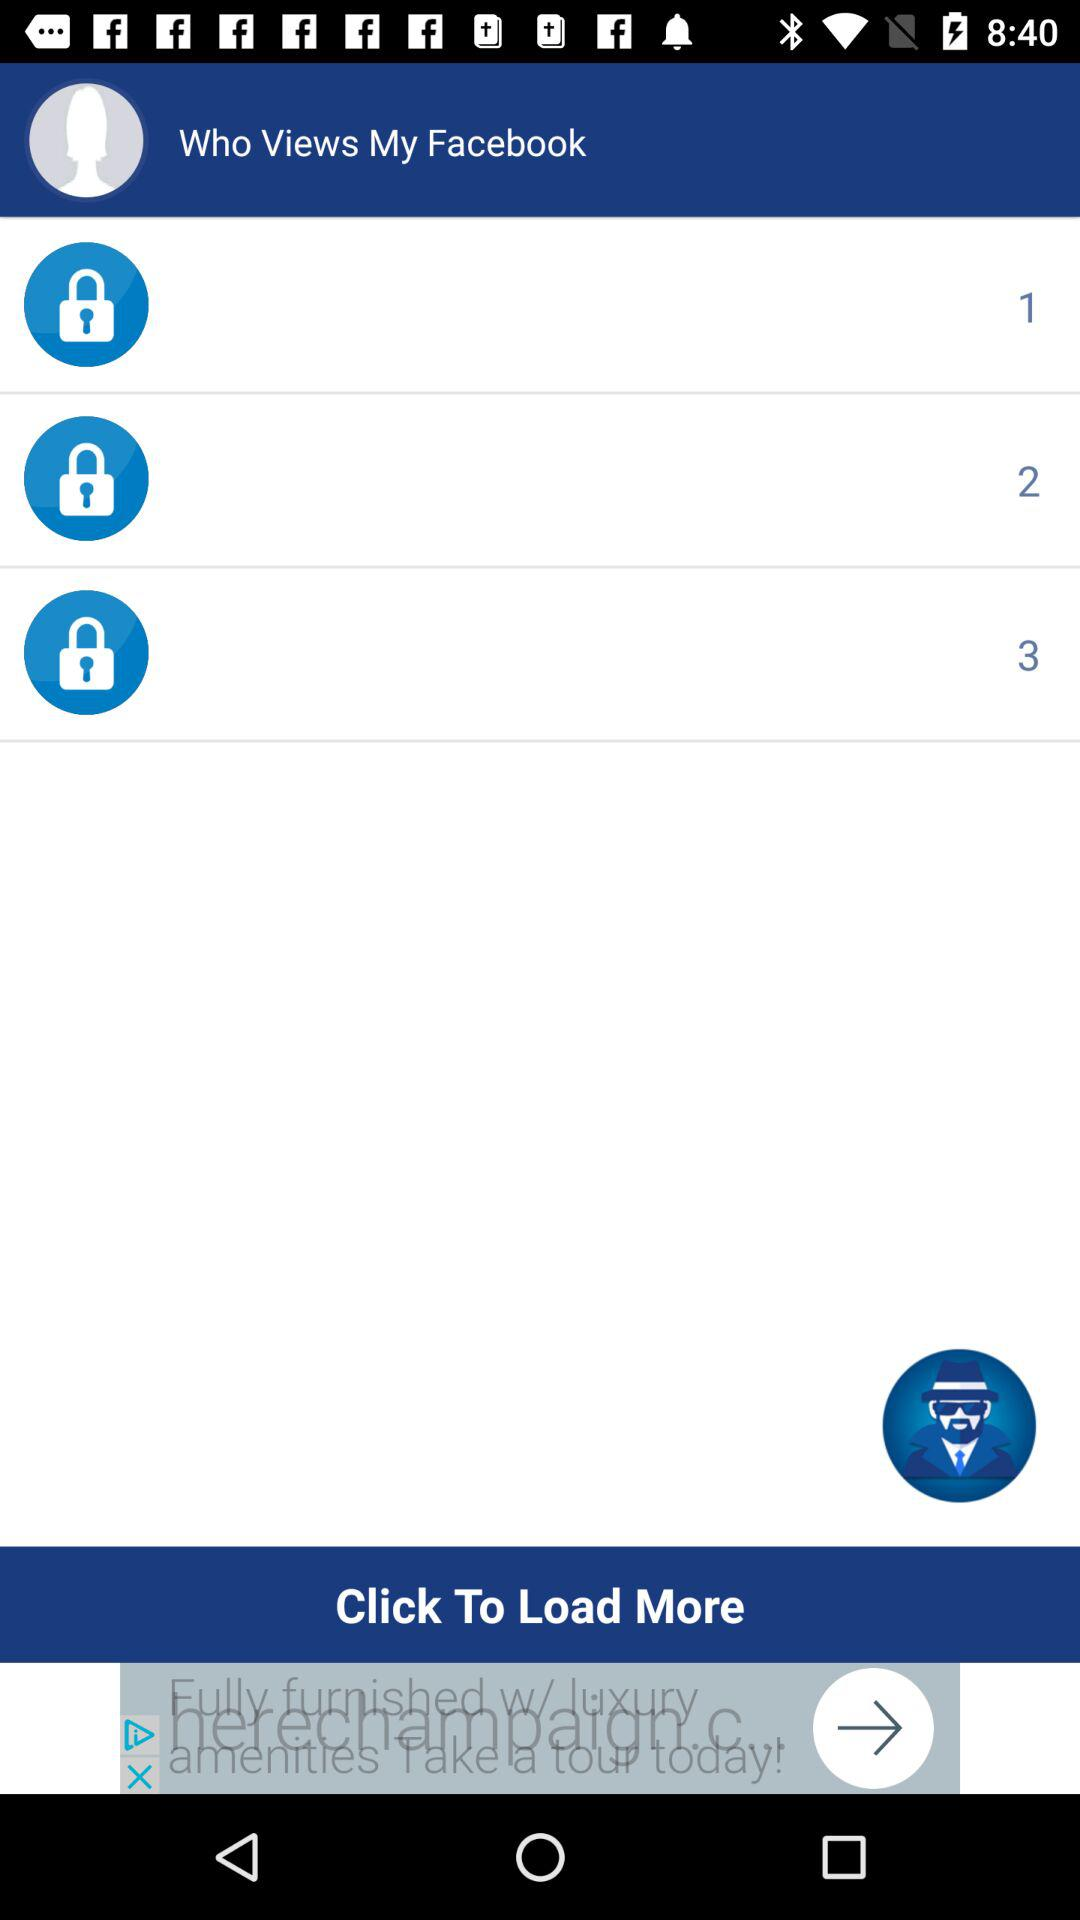How many users have viewed my Facebook?
Answer the question using a single word or phrase. 3 